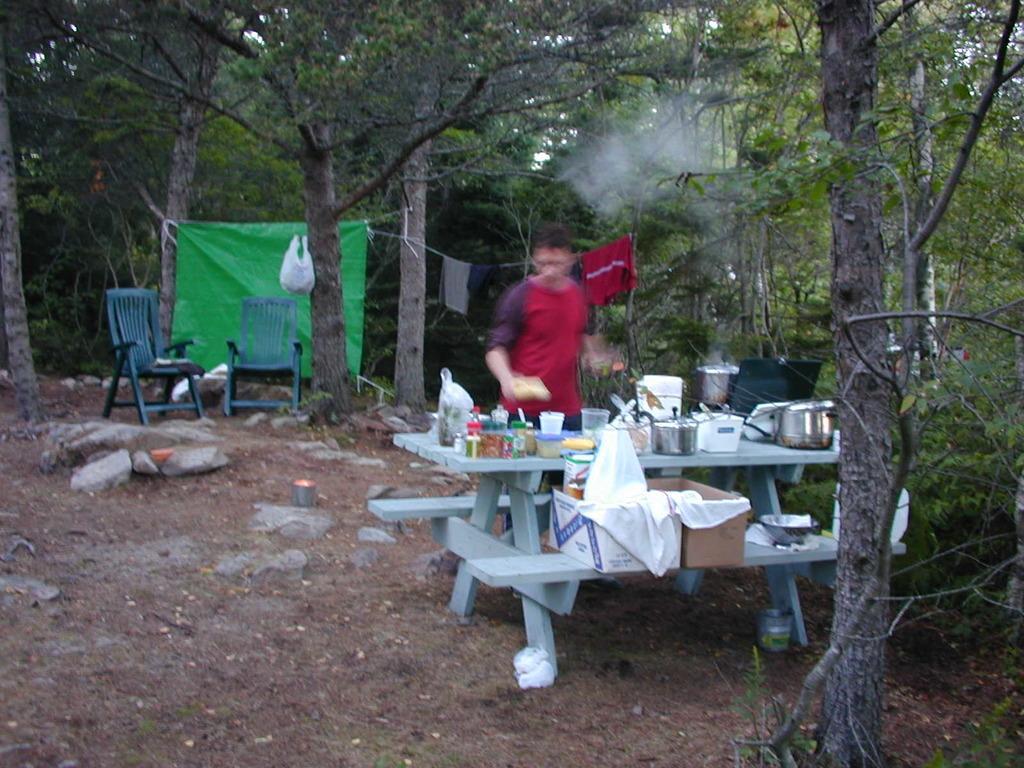Describe this image in one or two sentences. In this image I can see a person standing and the person is wearing red color shirt. In front I can see few utensils, glasses, bottles on the bench. Background I can see two chairs, a green color cloth and I can see trees in green color and the sky is in white color. 